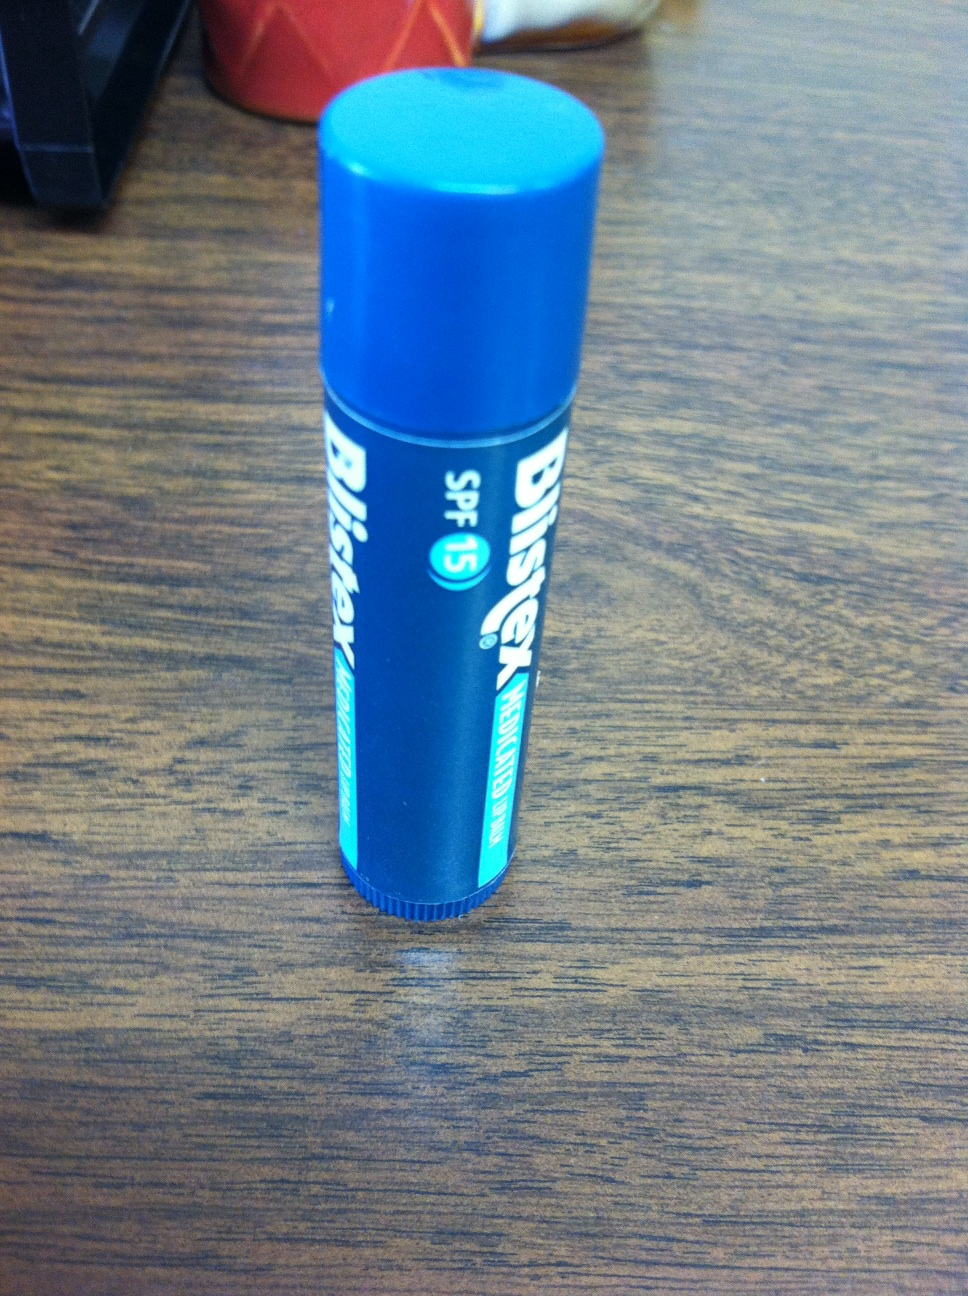What might happen if I didn't use this chapstick regularly? If you don't use this chapstick regularly, your lips might become dry, chapped, and more susceptible to damage from environmental factors like the sun, wind, and cold weather. Without the SPF protection, your lips are also at a higher risk of sunburn and long-term UV damage, which can lead to premature aging and increase the risk of skin cancer. Continuous use helps maintain lip moisture, health, and overall appearance. Could this chapstick be used for any fun DIY projects? While chapstick is primarily meant for lip care, it can be surprisingly versatile for various DIY projects! For instance, you can use it to fix a stuck zipper by rubbing a bit of chapstick along the zipper's teeth to lubricate it. It's also handy for soothing minor skin irritations or dry patches when you're in a pinch. Some people even use it to tame unruly eyebrows or as a quick moisturizer for cuticles. Its compact size and multi-functional properties make it a fun addition to your DIY toolkit! 